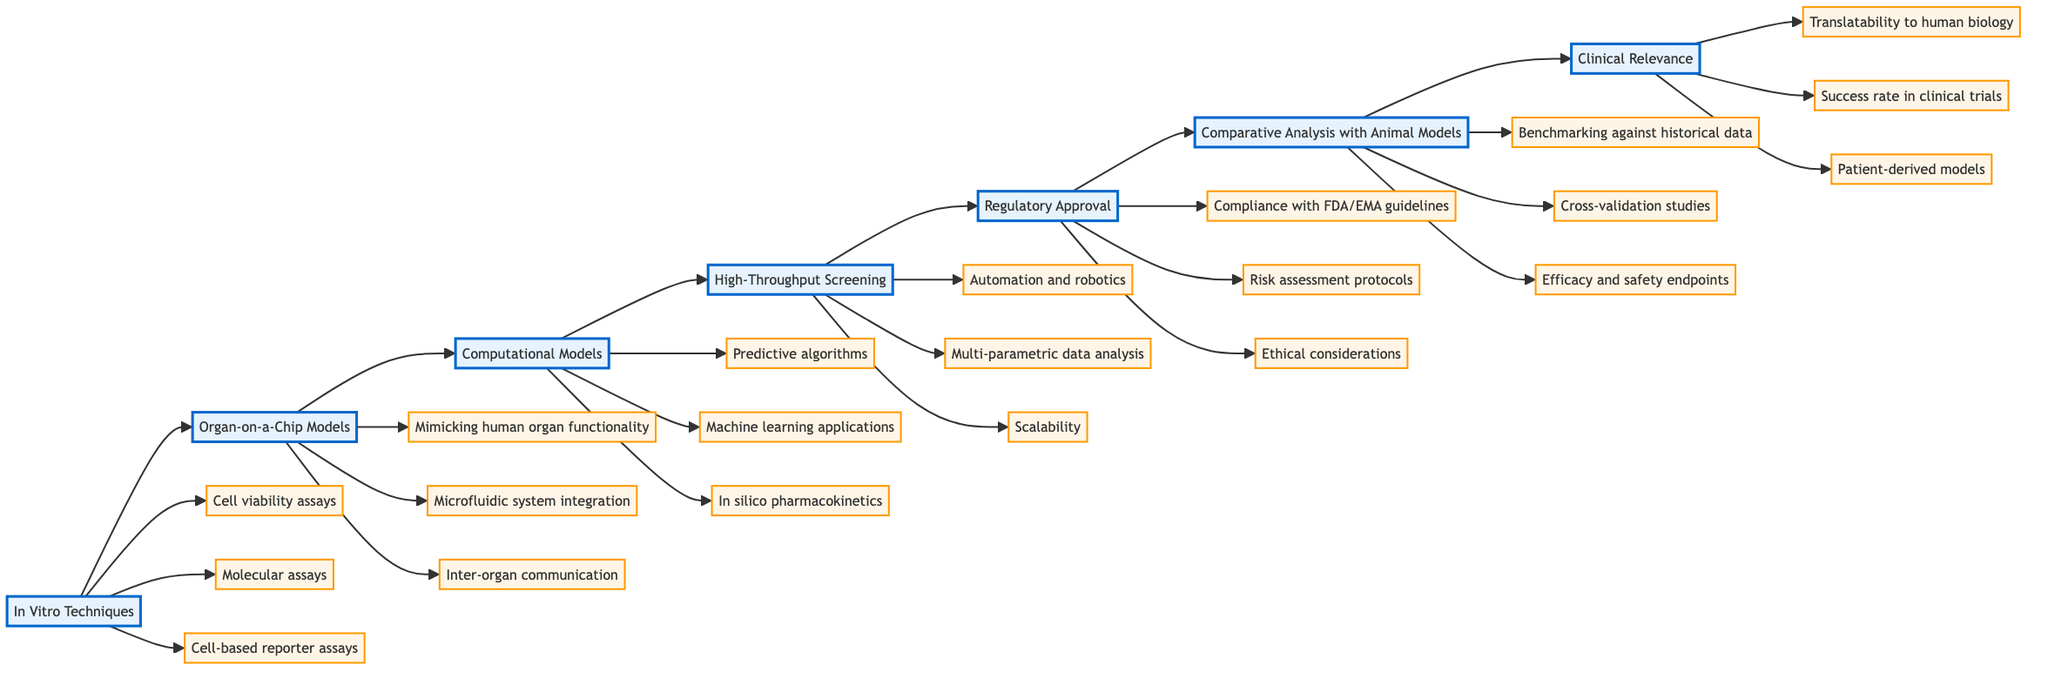What is the first step in the evaluation criteria? The first step in the evaluation criteria is represented by the node titled "In Vitro Techniques." This step is positioned at the beginning of the flowchart, indicating its importance as the initial criterion for alternative vaccine testing methods.
Answer: In Vitro Techniques How many criteria are listed under Organ-on-a-Chip Models? Under the node labeled "Organ-on-a-Chip Models," there are three specific criteria listed vertically. This can be determined by counting the nodes that branch out from it.
Answer: 3 What criteria follows High-Throughput Screening? Following the node "High-Throughput Screening," the next node in the flowchart is labeled "Regulatory Approval." This indicates the progression from screening methods to regulatory considerations.
Answer: Regulatory Approval What are the three criteria under Computational Models? The three criteria listed under "Computational Models" are "Predictive algorithms," "Machine learning applications," and "In silico pharmacokinetics." These criteria branch out from the main node, displaying their relevance to computational evaluations.
Answer: Predictive algorithms, Machine learning applications, In silico pharmacokinetics Which step contains criteria related to patient-derived models? The step containing criteria related to patient-derived models is "Clinical Relevance." This specific criterion indicates the focus on the applicability of results to human health issues.
Answer: Clinical Relevance Which step is directly before Comparative Analysis with Animal Models? The step directly preceding "Comparative Analysis with Animal Models" is "Regulatory Approval." This sequence illustrates the pathway from regulatory considerations to the evaluation against traditional animal models.
Answer: Regulatory Approval How many total steps are shown in the flowchart? The flowchart displays a total of seven distinct steps, represented by the nodes from "In Vitro Techniques" to "Clinical Relevance," outlined in a linear progression.
Answer: 7 What criteria is concerned with ethical considerations? The criteria associated with ethical considerations can be found under the "Regulatory Approval" step. This indicates that ethical aspects are vital in the approval process for alternative vaccine testing methods.
Answer: Ethical considerations 